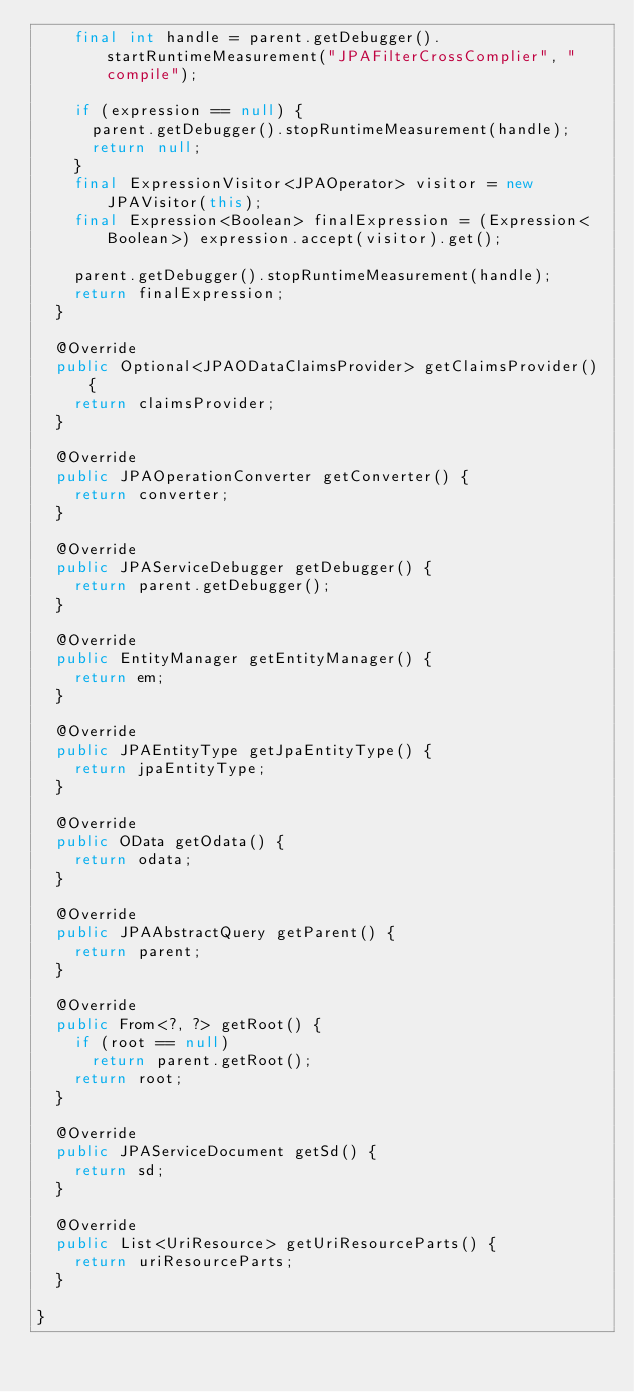<code> <loc_0><loc_0><loc_500><loc_500><_Java_>    final int handle = parent.getDebugger().startRuntimeMeasurement("JPAFilterCrossComplier", "compile");

    if (expression == null) {
      parent.getDebugger().stopRuntimeMeasurement(handle);
      return null;
    }
    final ExpressionVisitor<JPAOperator> visitor = new JPAVisitor(this);
    final Expression<Boolean> finalExpression = (Expression<Boolean>) expression.accept(visitor).get();

    parent.getDebugger().stopRuntimeMeasurement(handle);
    return finalExpression;
  }

  @Override
  public Optional<JPAODataClaimsProvider> getClaimsProvider() {
    return claimsProvider;
  }

  @Override
  public JPAOperationConverter getConverter() {
    return converter;
  }

  @Override
  public JPAServiceDebugger getDebugger() {
    return parent.getDebugger();
  }

  @Override
  public EntityManager getEntityManager() {
    return em;
  }

  @Override
  public JPAEntityType getJpaEntityType() {
    return jpaEntityType;
  }

  @Override
  public OData getOdata() {
    return odata;
  }

  @Override
  public JPAAbstractQuery getParent() {
    return parent;
  }

  @Override
  public From<?, ?> getRoot() {
    if (root == null)
      return parent.getRoot();
    return root;
  }

  @Override
  public JPAServiceDocument getSd() {
    return sd;
  }

  @Override
  public List<UriResource> getUriResourceParts() {
    return uriResourceParts;
  }

}
</code> 